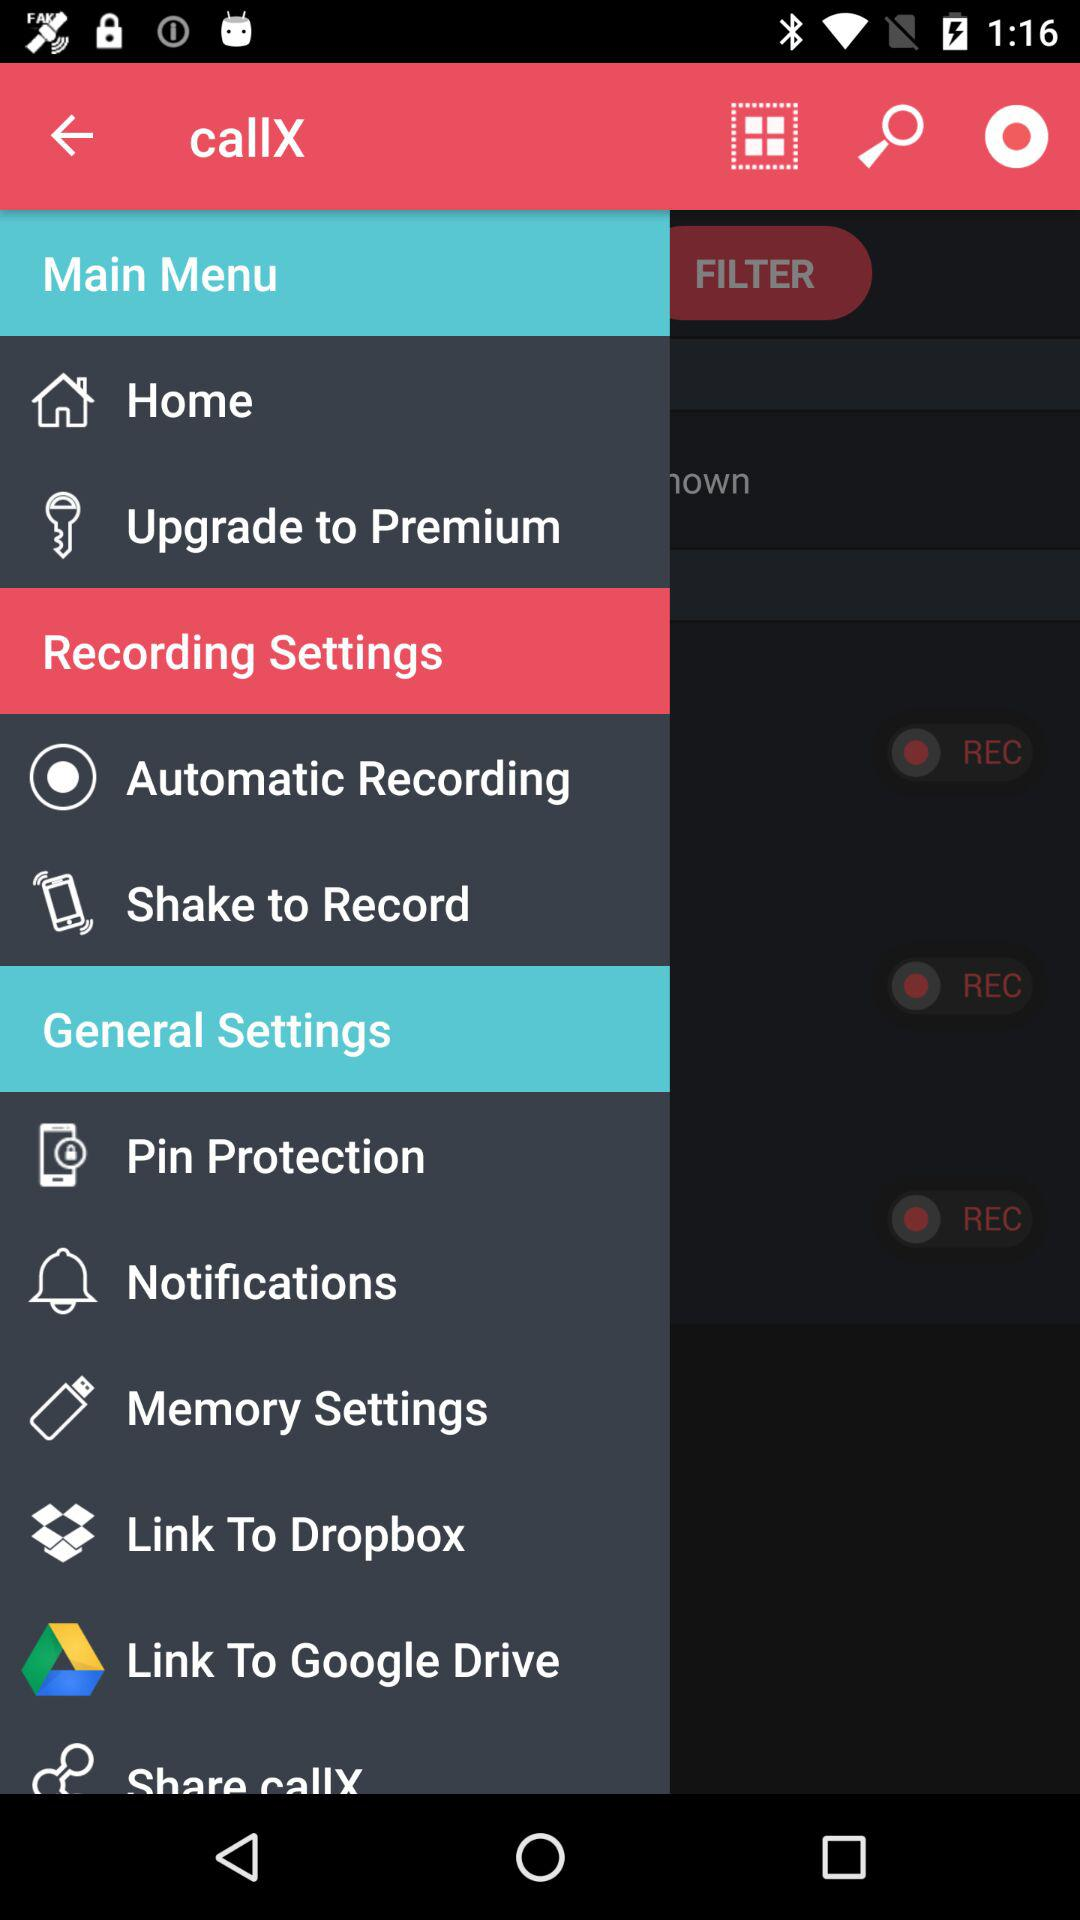What is the application name? The application name is "callX". 